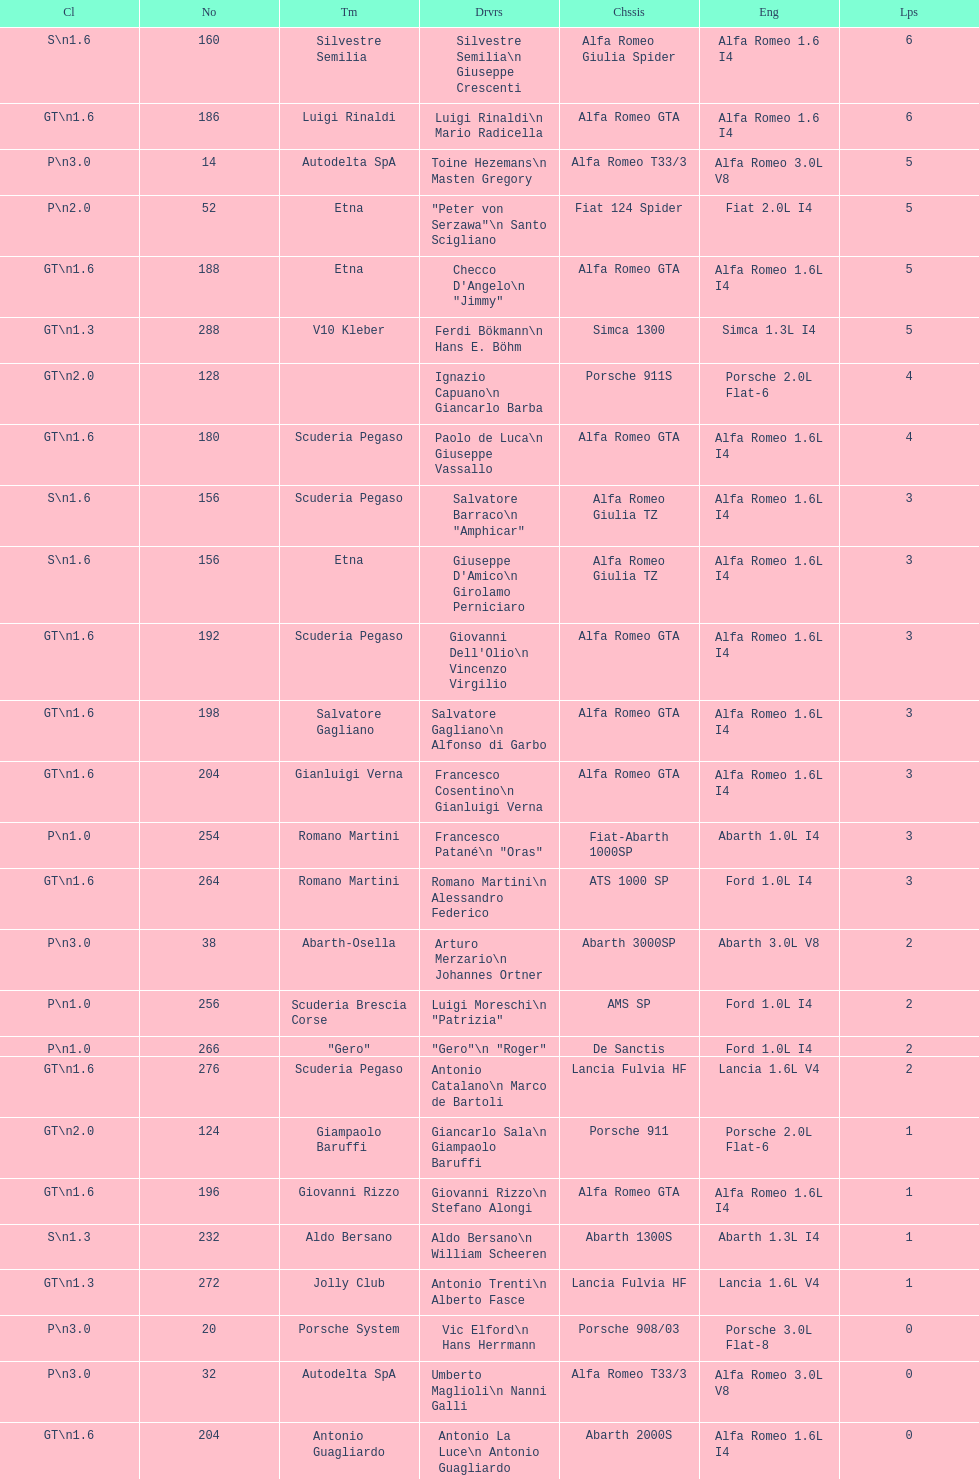How many drivers are from italy? 48. 